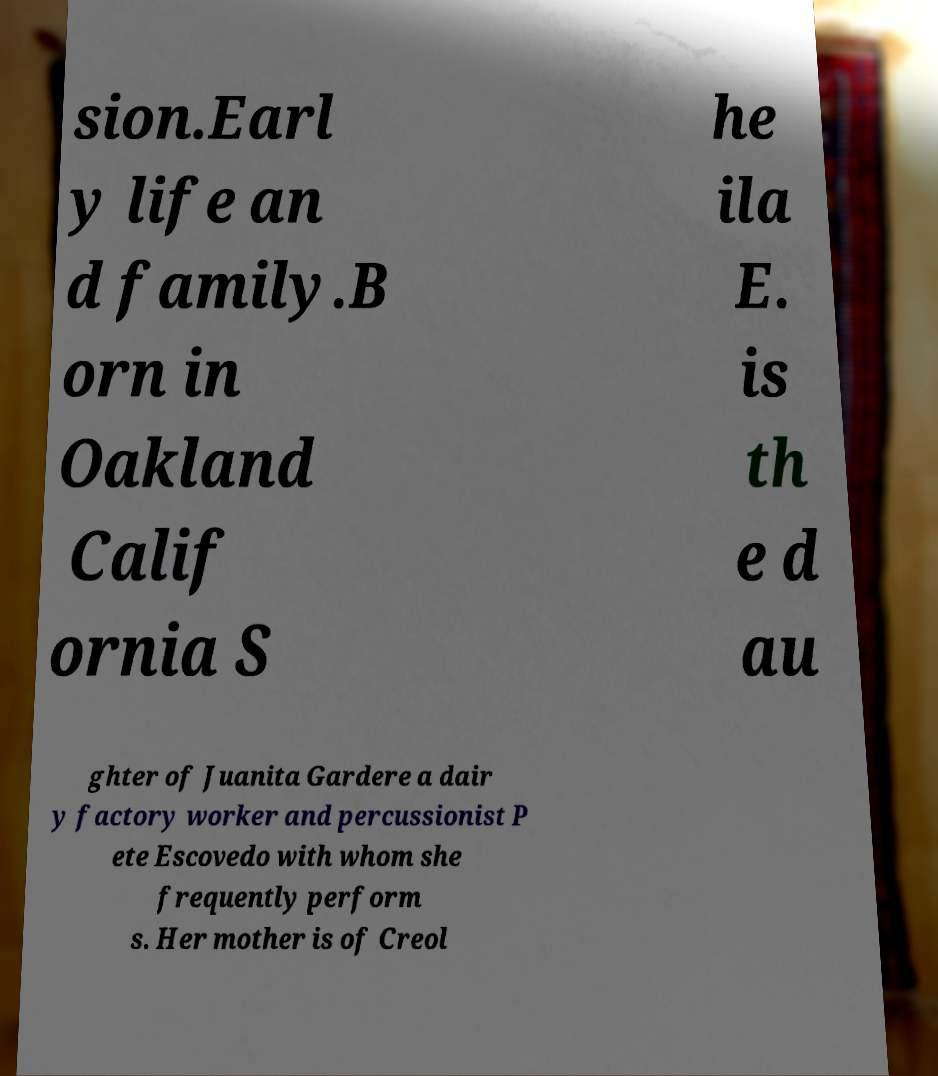Can you accurately transcribe the text from the provided image for me? sion.Earl y life an d family.B orn in Oakland Calif ornia S he ila E. is th e d au ghter of Juanita Gardere a dair y factory worker and percussionist P ete Escovedo with whom she frequently perform s. Her mother is of Creol 